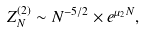<formula> <loc_0><loc_0><loc_500><loc_500>Z ^ { ( 2 ) } _ { N } \sim N ^ { - 5 / 2 } \times e ^ { \mu _ { 2 } N } ,</formula> 